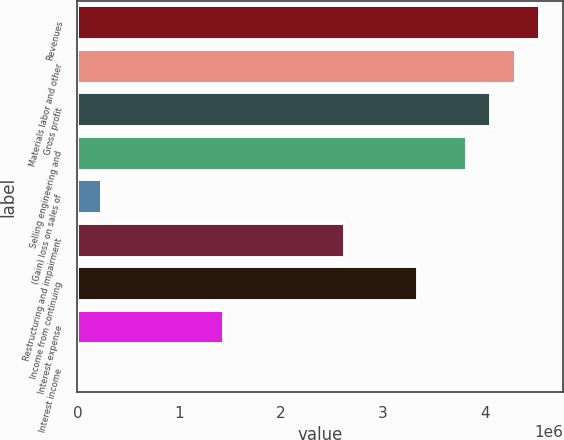<chart> <loc_0><loc_0><loc_500><loc_500><bar_chart><fcel>Revenues<fcel>Materials labor and other<fcel>Gross profit<fcel>Selling engineering and<fcel>(Gain) loss on sales of<fcel>Restructuring and impairment<fcel>Income from continuing<fcel>Interest expense<fcel>Interest income<nl><fcel>4.54127e+06<fcel>4.30229e+06<fcel>4.0633e+06<fcel>3.82432e+06<fcel>239550<fcel>2.6294e+06<fcel>3.34635e+06<fcel>1.43447e+06<fcel>565<nl></chart> 